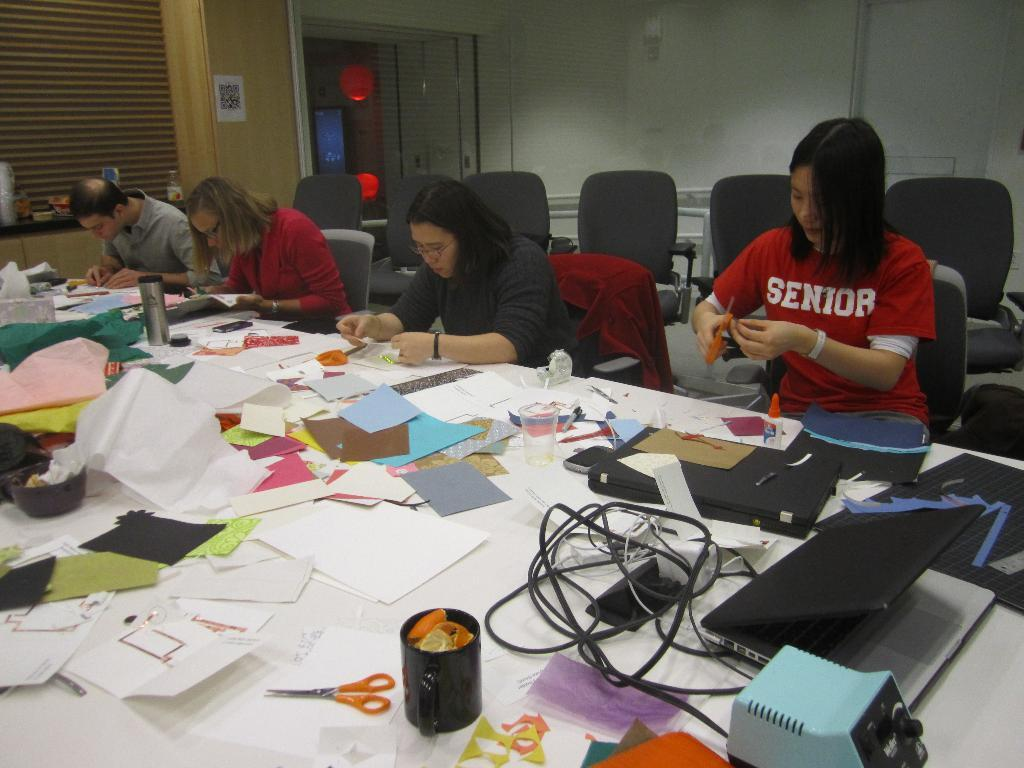<image>
Render a clear and concise summary of the photo. The person in the red shirt is a Senior at the school 